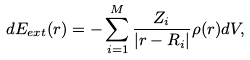<formula> <loc_0><loc_0><loc_500><loc_500>d E _ { e x t } ( { r } ) = - \sum _ { i = 1 } ^ { M } \frac { Z _ { i } } { | { r } - { R } _ { i } | } \rho ( { r } ) d V ,</formula> 